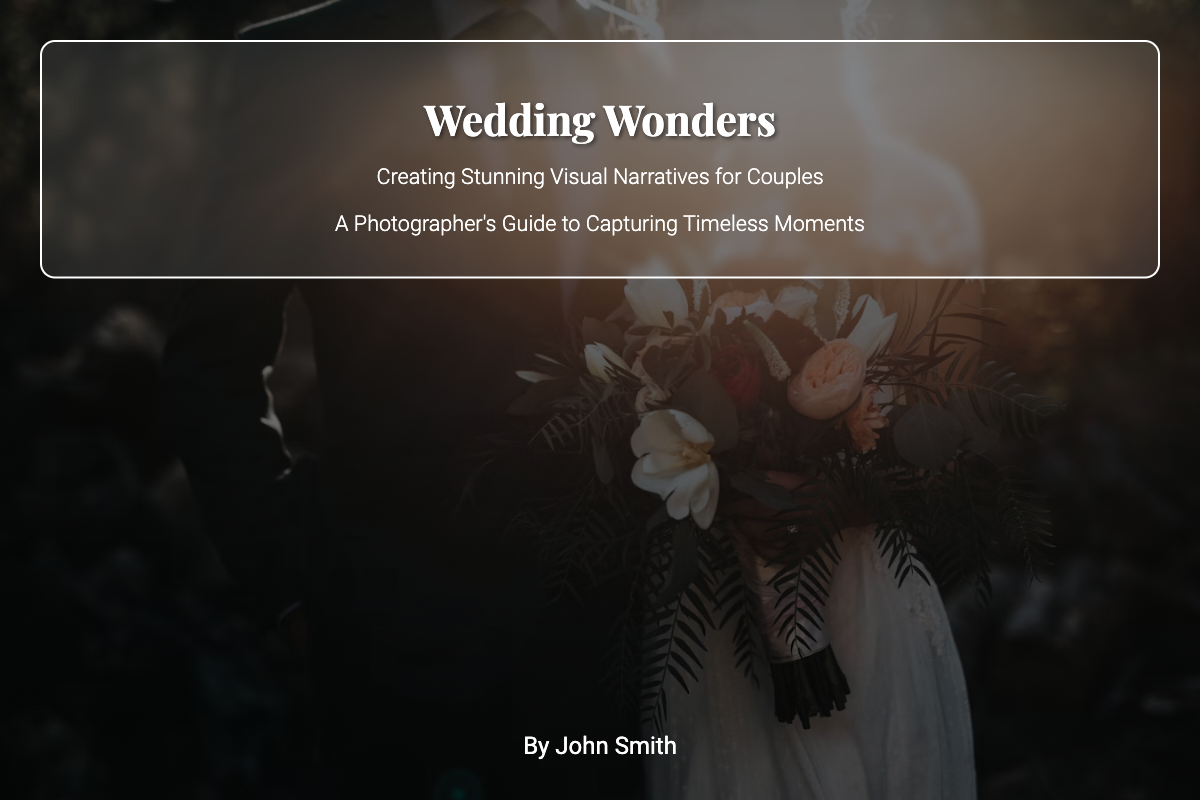What is the book title? The book title is prominently displayed on the cover in large font.
Answer: Wedding Wonders What is the subtitle of the book? The subtitle provides more detail about the book's focus and is located directly below the title.
Answer: Creating Stunning Visual Narratives for Couples Who is the author of the book? The author's name is presented at the bottom of the cover in a distinct font.
Answer: John Smith What type of guide is this book? This describes the nature of the content the book provides, which can be inferred from the subtitle.
Answer: A Photographer's Guide What is the background image of the cover? The background image features a romantic scene important to the book's theme.
Answer: A couple against a sunset backdrop What is the general color theme of the book cover? The overall colors used in the design suggest a mood associated with weddings.
Answer: Vibrant and soft tones How many subtitles are presented on the cover? Subtitles provide additional context about the content of the book; they are listed under the main title.
Answer: Two subtitles What design feature enhances text readability on the cover? This feature is added to improve the contrast between text and background imagery.
Answer: Cover overlay What visual effect is used in the book cover design? This effect adds depth and a soft focus to the imagery, contributing to visual appeal.
Answer: Blur effect 